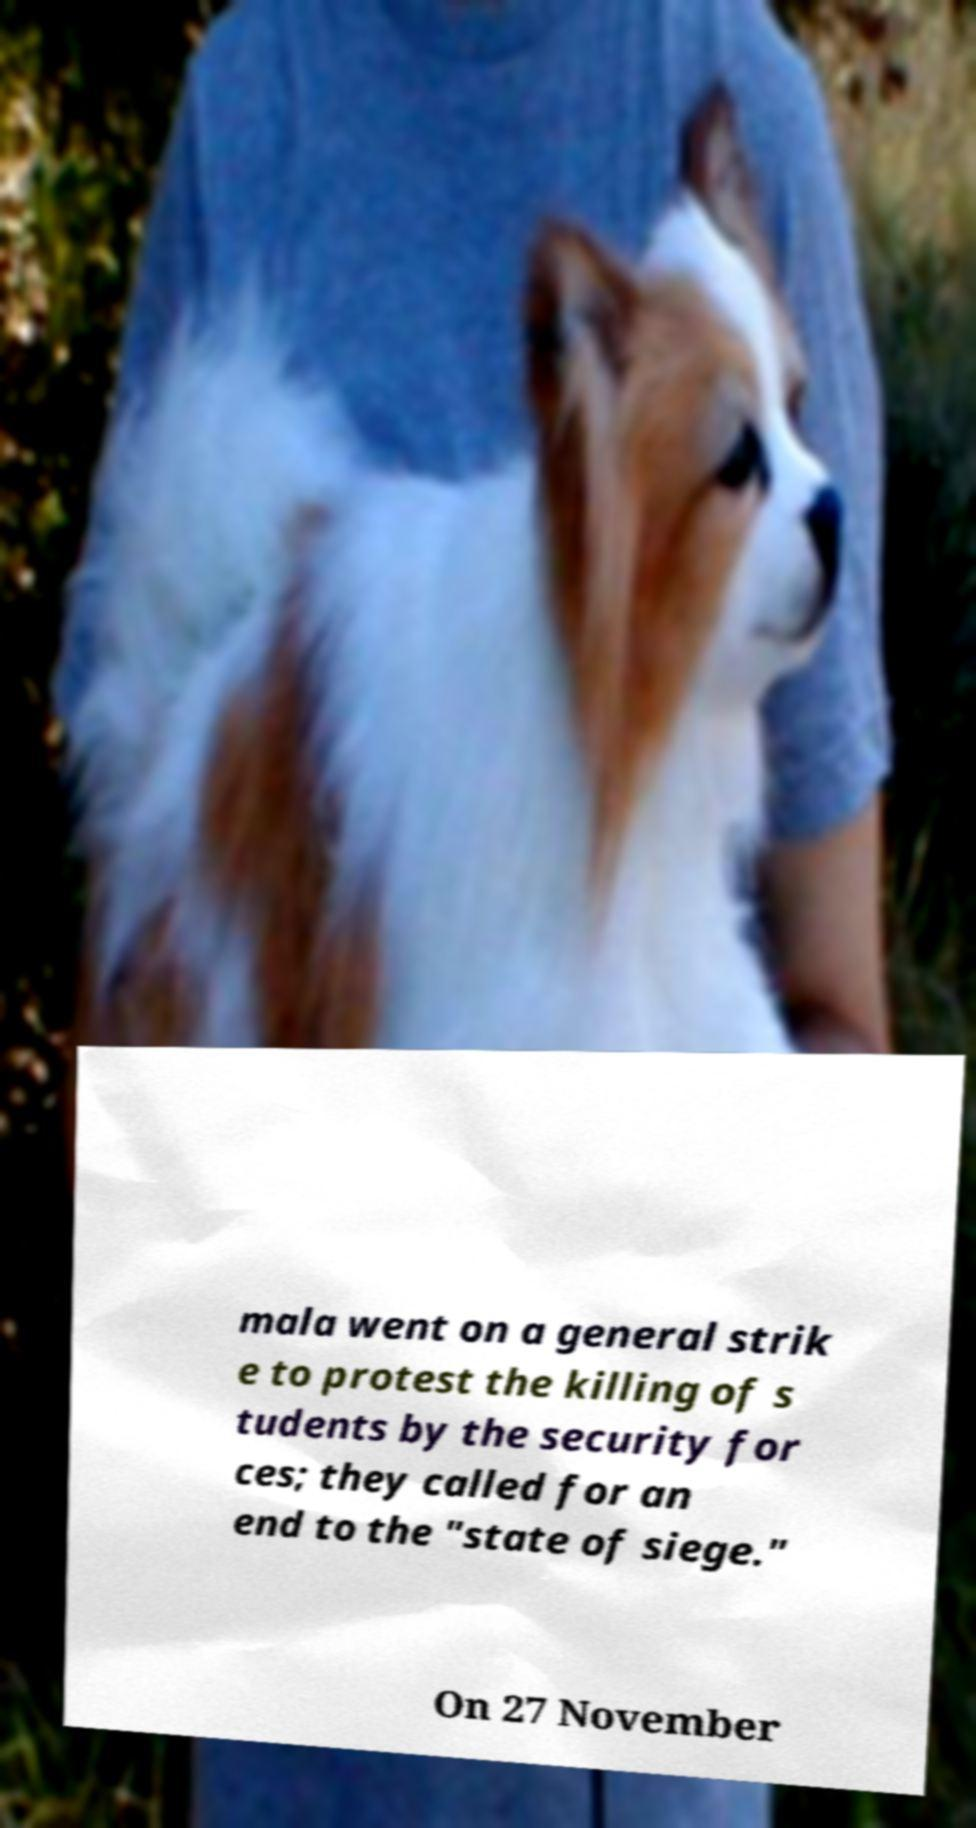Please identify and transcribe the text found in this image. mala went on a general strik e to protest the killing of s tudents by the security for ces; they called for an end to the "state of siege." On 27 November 